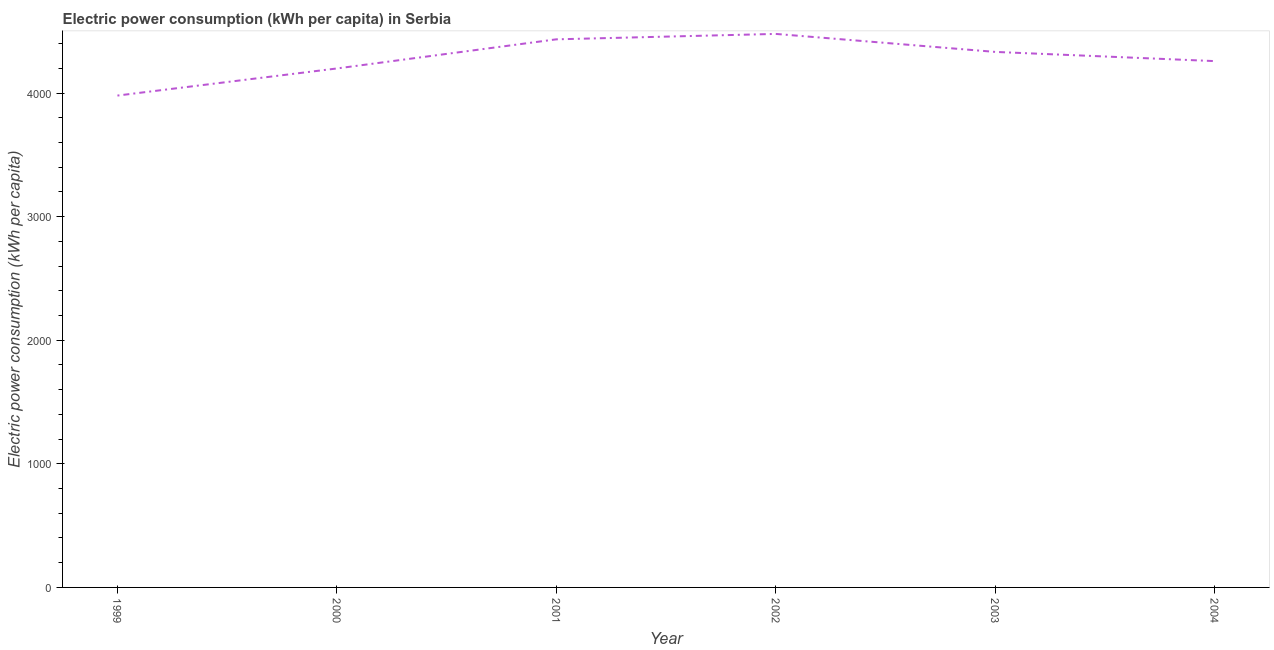What is the electric power consumption in 2003?
Keep it short and to the point. 4332.68. Across all years, what is the maximum electric power consumption?
Give a very brief answer. 4478.25. Across all years, what is the minimum electric power consumption?
Provide a succinct answer. 3979.36. In which year was the electric power consumption maximum?
Keep it short and to the point. 2002. In which year was the electric power consumption minimum?
Offer a terse response. 1999. What is the sum of the electric power consumption?
Your answer should be compact. 2.57e+04. What is the difference between the electric power consumption in 2000 and 2003?
Ensure brevity in your answer.  -133.96. What is the average electric power consumption per year?
Keep it short and to the point. 4280.27. What is the median electric power consumption?
Provide a short and direct response. 4295.47. Do a majority of the years between 2001 and 2000 (inclusive) have electric power consumption greater than 2600 kWh per capita?
Your answer should be compact. No. What is the ratio of the electric power consumption in 1999 to that in 2003?
Provide a short and direct response. 0.92. Is the electric power consumption in 1999 less than that in 2003?
Ensure brevity in your answer.  Yes. Is the difference between the electric power consumption in 2000 and 2003 greater than the difference between any two years?
Your response must be concise. No. What is the difference between the highest and the second highest electric power consumption?
Offer a very short reply. 43.88. Is the sum of the electric power consumption in 2002 and 2004 greater than the maximum electric power consumption across all years?
Keep it short and to the point. Yes. What is the difference between the highest and the lowest electric power consumption?
Your response must be concise. 498.88. In how many years, is the electric power consumption greater than the average electric power consumption taken over all years?
Your answer should be very brief. 3. How many years are there in the graph?
Make the answer very short. 6. What is the difference between two consecutive major ticks on the Y-axis?
Offer a very short reply. 1000. Does the graph contain any zero values?
Offer a very short reply. No. Does the graph contain grids?
Provide a succinct answer. No. What is the title of the graph?
Ensure brevity in your answer.  Electric power consumption (kWh per capita) in Serbia. What is the label or title of the X-axis?
Ensure brevity in your answer.  Year. What is the label or title of the Y-axis?
Provide a short and direct response. Electric power consumption (kWh per capita). What is the Electric power consumption (kWh per capita) of 1999?
Offer a terse response. 3979.36. What is the Electric power consumption (kWh per capita) of 2000?
Make the answer very short. 4198.72. What is the Electric power consumption (kWh per capita) in 2001?
Provide a succinct answer. 4434.37. What is the Electric power consumption (kWh per capita) in 2002?
Your answer should be compact. 4478.25. What is the Electric power consumption (kWh per capita) in 2003?
Make the answer very short. 4332.68. What is the Electric power consumption (kWh per capita) of 2004?
Your response must be concise. 4258.25. What is the difference between the Electric power consumption (kWh per capita) in 1999 and 2000?
Keep it short and to the point. -219.35. What is the difference between the Electric power consumption (kWh per capita) in 1999 and 2001?
Ensure brevity in your answer.  -455.01. What is the difference between the Electric power consumption (kWh per capita) in 1999 and 2002?
Ensure brevity in your answer.  -498.88. What is the difference between the Electric power consumption (kWh per capita) in 1999 and 2003?
Your answer should be compact. -353.32. What is the difference between the Electric power consumption (kWh per capita) in 1999 and 2004?
Give a very brief answer. -278.89. What is the difference between the Electric power consumption (kWh per capita) in 2000 and 2001?
Offer a terse response. -235.65. What is the difference between the Electric power consumption (kWh per capita) in 2000 and 2002?
Provide a short and direct response. -279.53. What is the difference between the Electric power consumption (kWh per capita) in 2000 and 2003?
Make the answer very short. -133.96. What is the difference between the Electric power consumption (kWh per capita) in 2000 and 2004?
Provide a succinct answer. -59.54. What is the difference between the Electric power consumption (kWh per capita) in 2001 and 2002?
Your answer should be very brief. -43.88. What is the difference between the Electric power consumption (kWh per capita) in 2001 and 2003?
Offer a very short reply. 101.69. What is the difference between the Electric power consumption (kWh per capita) in 2001 and 2004?
Your response must be concise. 176.12. What is the difference between the Electric power consumption (kWh per capita) in 2002 and 2003?
Ensure brevity in your answer.  145.57. What is the difference between the Electric power consumption (kWh per capita) in 2002 and 2004?
Give a very brief answer. 220. What is the difference between the Electric power consumption (kWh per capita) in 2003 and 2004?
Keep it short and to the point. 74.43. What is the ratio of the Electric power consumption (kWh per capita) in 1999 to that in 2000?
Keep it short and to the point. 0.95. What is the ratio of the Electric power consumption (kWh per capita) in 1999 to that in 2001?
Keep it short and to the point. 0.9. What is the ratio of the Electric power consumption (kWh per capita) in 1999 to that in 2002?
Your response must be concise. 0.89. What is the ratio of the Electric power consumption (kWh per capita) in 1999 to that in 2003?
Your answer should be very brief. 0.92. What is the ratio of the Electric power consumption (kWh per capita) in 1999 to that in 2004?
Offer a terse response. 0.94. What is the ratio of the Electric power consumption (kWh per capita) in 2000 to that in 2001?
Ensure brevity in your answer.  0.95. What is the ratio of the Electric power consumption (kWh per capita) in 2000 to that in 2002?
Ensure brevity in your answer.  0.94. What is the ratio of the Electric power consumption (kWh per capita) in 2000 to that in 2004?
Make the answer very short. 0.99. What is the ratio of the Electric power consumption (kWh per capita) in 2001 to that in 2002?
Offer a terse response. 0.99. What is the ratio of the Electric power consumption (kWh per capita) in 2001 to that in 2003?
Offer a very short reply. 1.02. What is the ratio of the Electric power consumption (kWh per capita) in 2001 to that in 2004?
Provide a short and direct response. 1.04. What is the ratio of the Electric power consumption (kWh per capita) in 2002 to that in 2003?
Ensure brevity in your answer.  1.03. What is the ratio of the Electric power consumption (kWh per capita) in 2002 to that in 2004?
Provide a succinct answer. 1.05. 